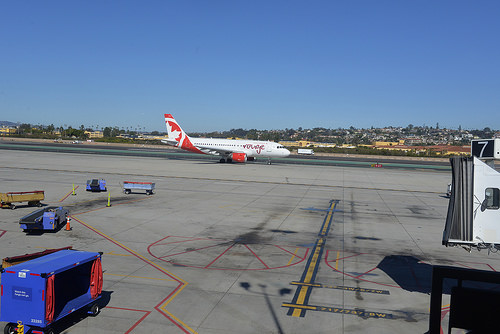<image>
Is there a airplane on the runway? Yes. Looking at the image, I can see the airplane is positioned on top of the runway, with the runway providing support. 